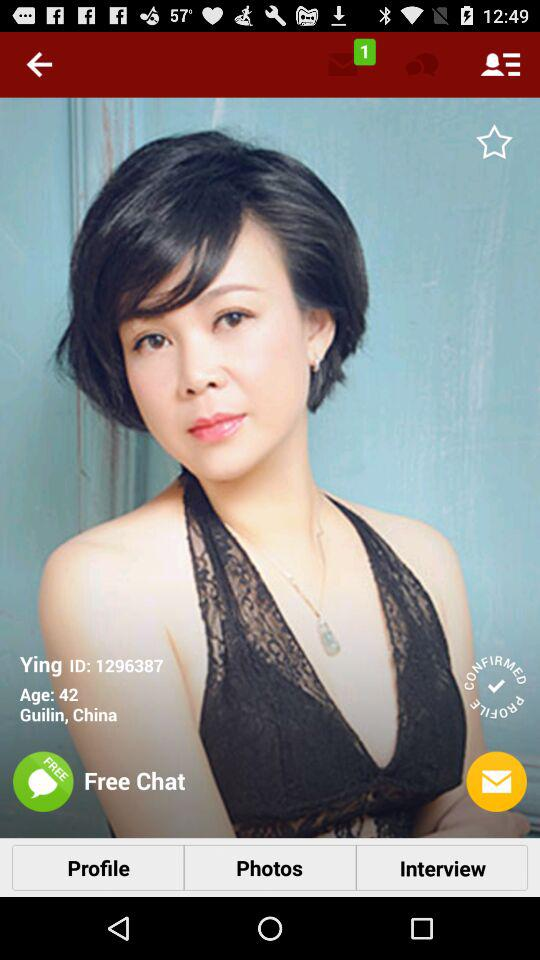How many messages are unread? There is 1 unread message. 